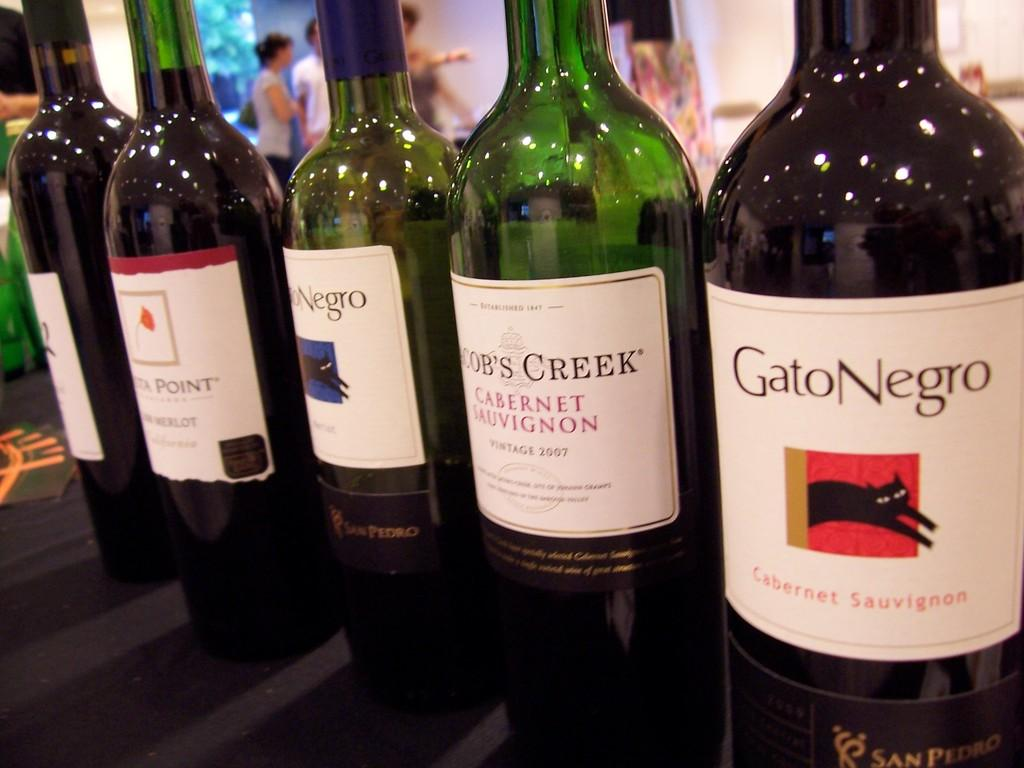Provide a one-sentence caption for the provided image. Bottles of wine are lined up, including a cabernet by Gato Negro. 